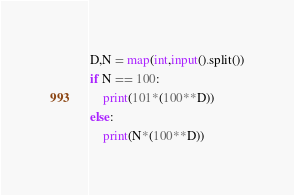<code> <loc_0><loc_0><loc_500><loc_500><_Python_>D,N = map(int,input().split())
if N == 100:
    print(101*(100**D))
else:
    print(N*(100**D))
</code> 